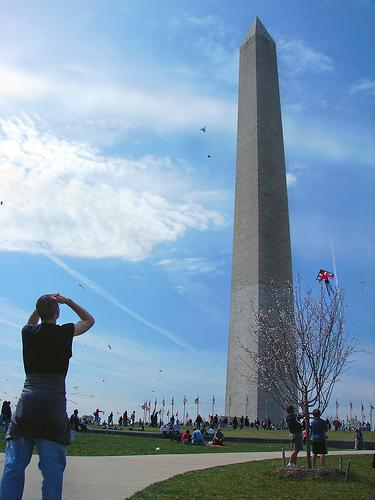Question: where does the man have his hands?
Choices:
A. In his pocket.
B. On his head.
C. On the table.
D. Cross his chest.
Answer with the letter. Answer: B Question: why is the guy looking up in the sky?
Choices:
A. The tall building.
B. At the plane.
C. At the kite.
D. At the eclipse.
Answer with the letter. Answer: A Question: what does the man have around his waist?
Choices:
A. A belt.
B. A fanny pack.
C. A jacket.
D. Tools.
Answer with the letter. Answer: C 